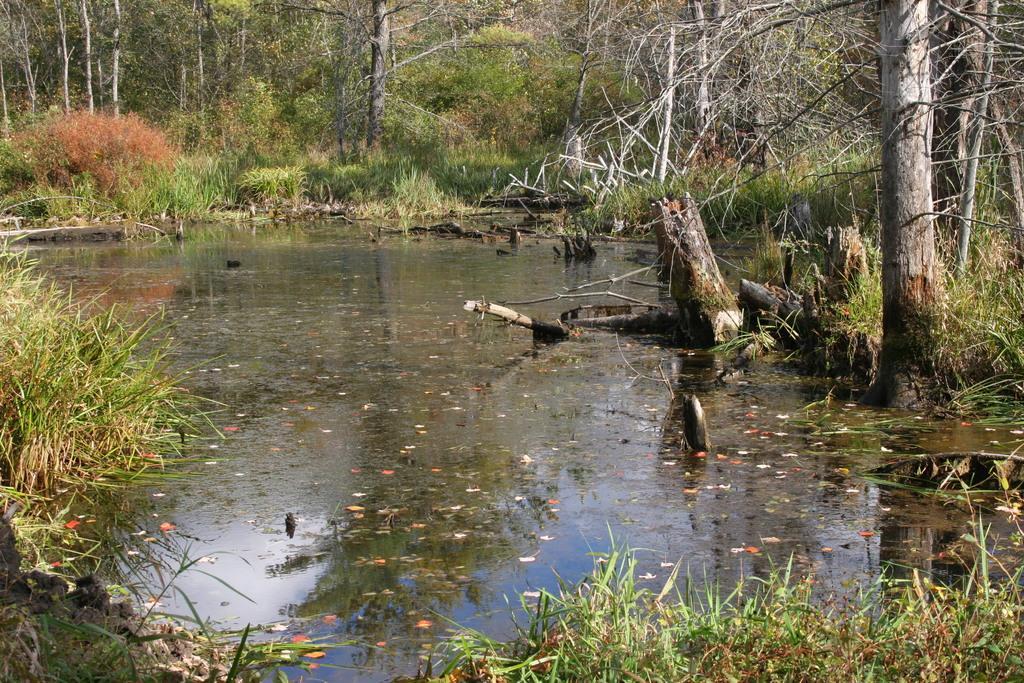Could you give a brief overview of what you see in this image? This image consists of water. It looks like it is clicked in a forest. To the left, there is a grass. In the background, there are plants and trees. 